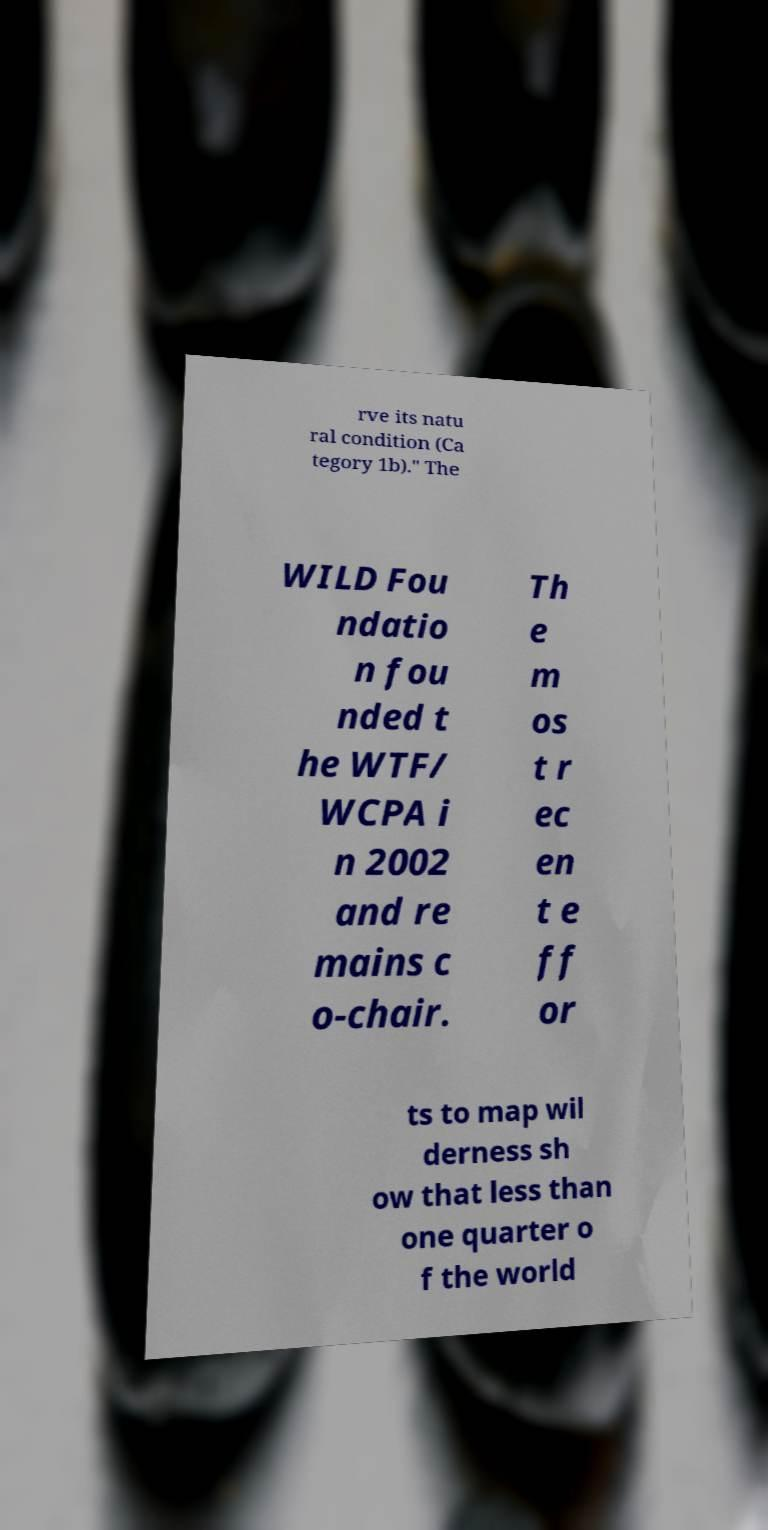Please read and relay the text visible in this image. What does it say? rve its natu ral condition (Ca tegory 1b)." The WILD Fou ndatio n fou nded t he WTF/ WCPA i n 2002 and re mains c o-chair. Th e m os t r ec en t e ff or ts to map wil derness sh ow that less than one quarter o f the world 